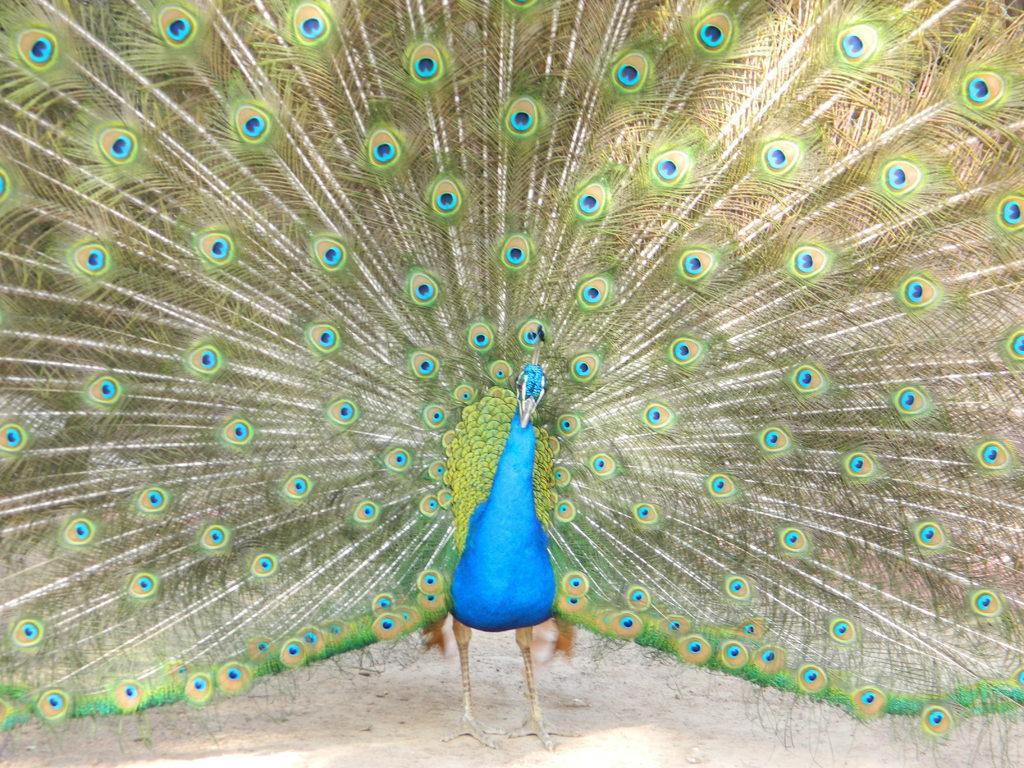Could you give a brief overview of what you see in this image? In this picture we can see a peacock on the ground. 